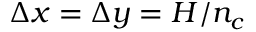Convert formula to latex. <formula><loc_0><loc_0><loc_500><loc_500>\Delta x = \Delta y = H / n _ { c }</formula> 